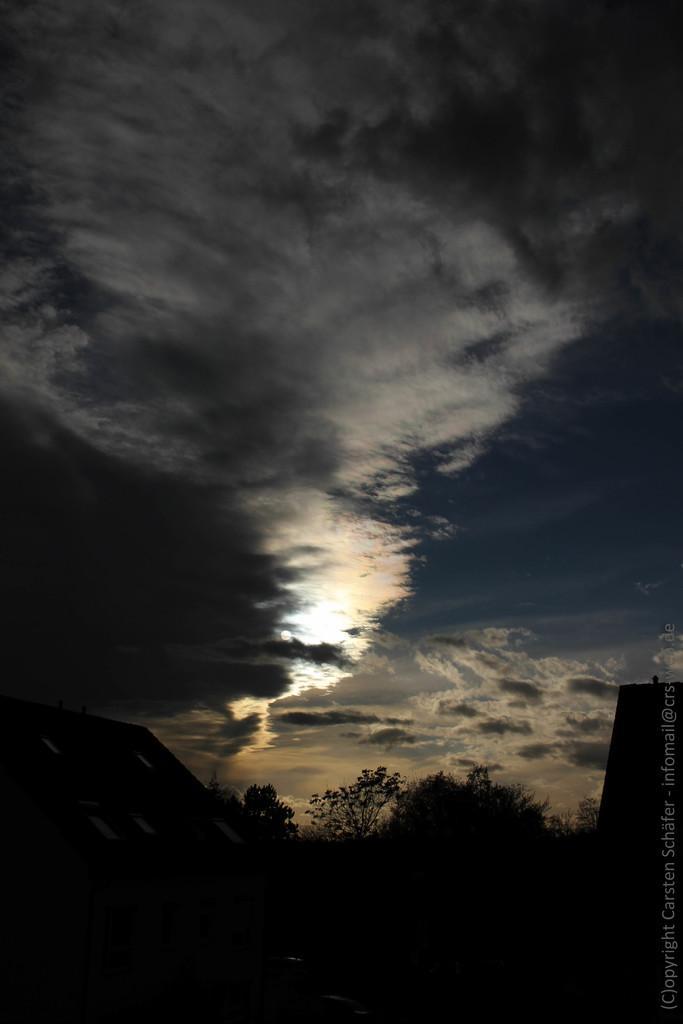Describe this image in one or two sentences. In the image in the center we can see trees and house. On the right side of the image,there is a watermark. In the background we can see the sky and clouds. 